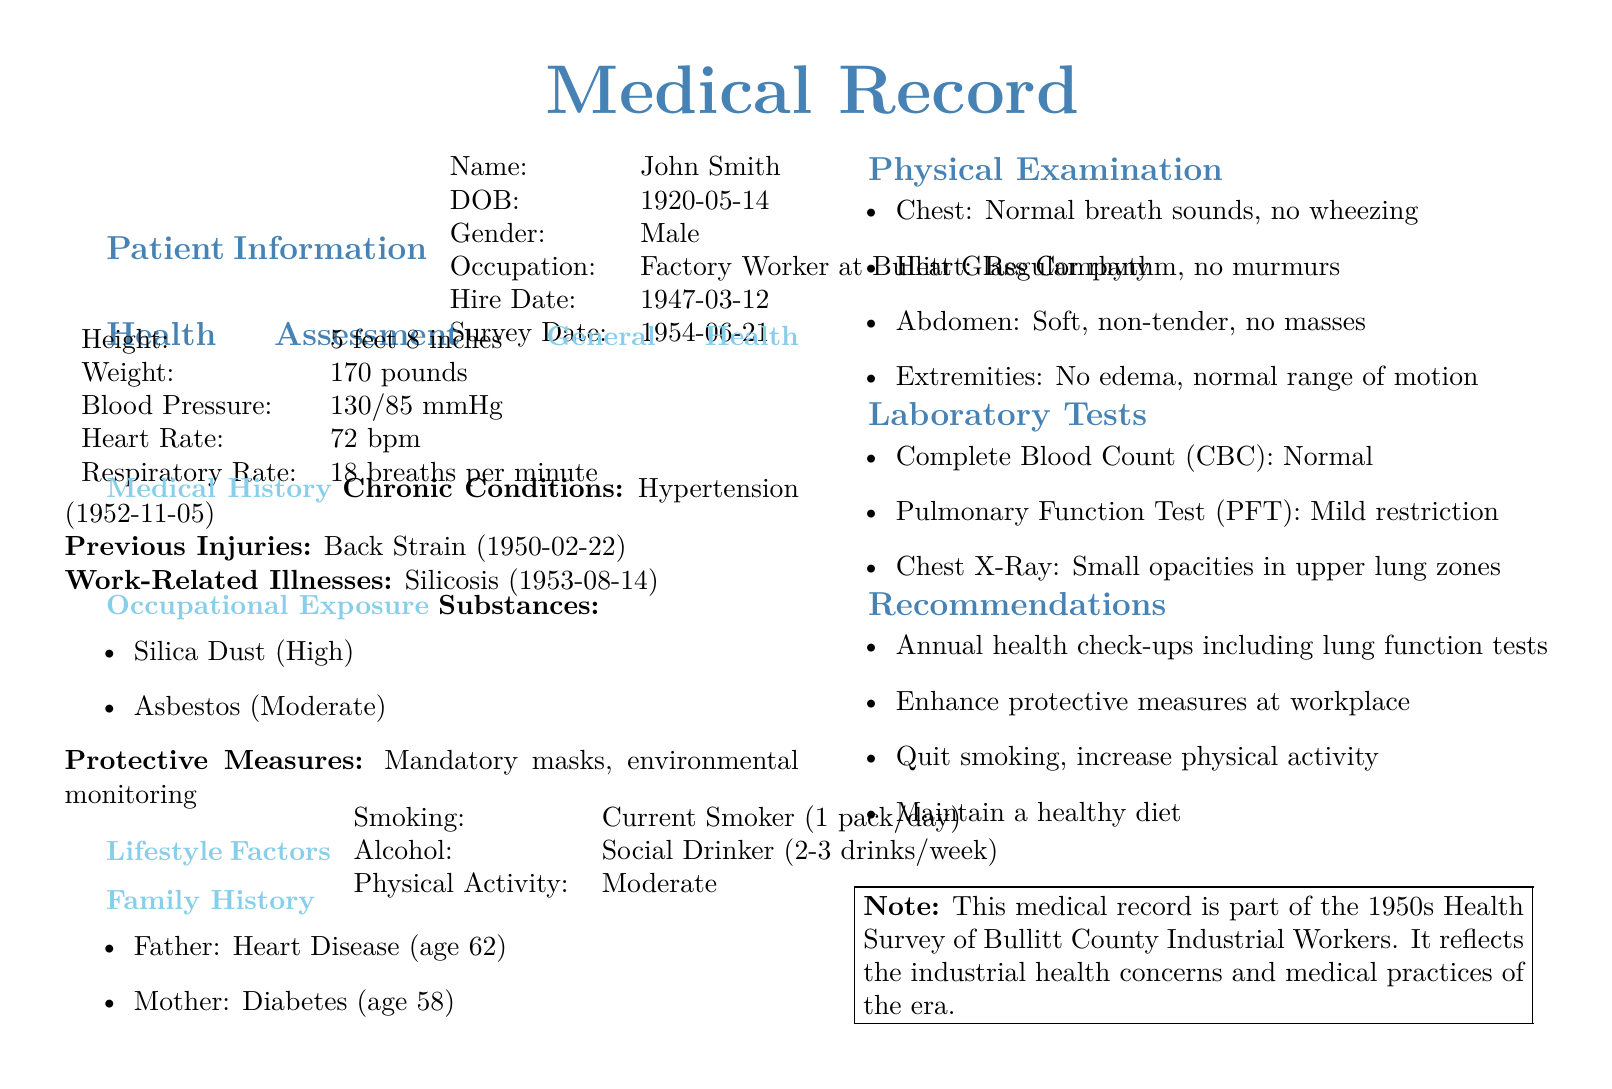What is the name of the patient? The name of the patient is provided in the patient information section of the document.
Answer: John Smith What is the date of birth of the patient? The date of birth can be found in the patient information section.
Answer: 1920-05-14 What chronic condition does the patient have? The document lists the patient's chronic conditions under medical history.
Answer: Hypertension What is the patient's occupation? The occupation of the patient is listed in the patient information section.
Answer: Factory Worker at Bullitt Glass Company What was the survey date? The survey date is indicated in the patient information section of the document.
Answer: 1954-06-21 Which substance has high exposure for the patient? The occupational exposure section specifies substances with their exposure levels.
Answer: Silica Dust What was noted in the chest physical examination? The physical examination section mentions findings related to the chest.
Answer: Normal breath sounds, no wheezing What is the result of the pulmonary function test? The laboratory tests section describes the pulmonary function test outcome.
Answer: Mild restriction What recommendations were made for the patient? The recommendations are listed in their own section of the document.
Answer: Annual health check-ups including lung function tests What family health issue is noted for the father? The family history section outlines health issues that family members have experienced.
Answer: Heart Disease 